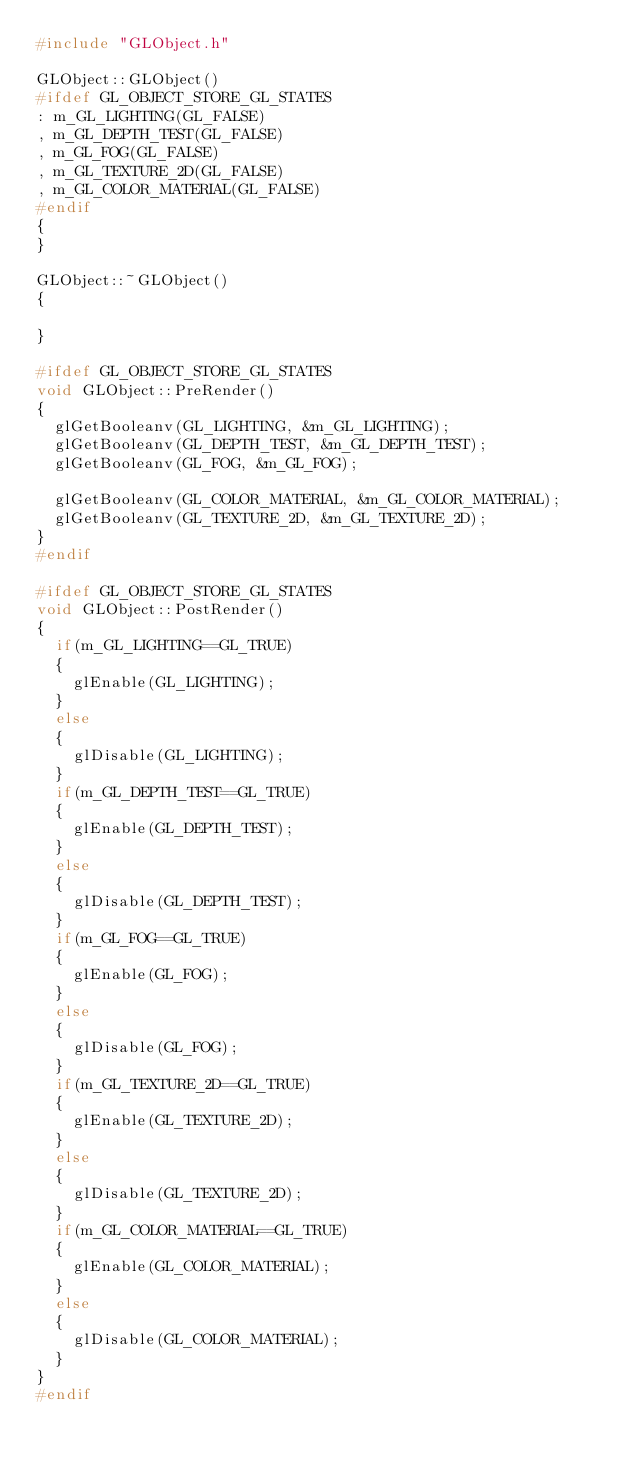Convert code to text. <code><loc_0><loc_0><loc_500><loc_500><_C++_>#include "GLObject.h"

GLObject::GLObject()
#ifdef GL_OBJECT_STORE_GL_STATES
: m_GL_LIGHTING(GL_FALSE)
, m_GL_DEPTH_TEST(GL_FALSE)
, m_GL_FOG(GL_FALSE)
, m_GL_TEXTURE_2D(GL_FALSE)
, m_GL_COLOR_MATERIAL(GL_FALSE)
#endif
{
}

GLObject::~GLObject()
{

}

#ifdef GL_OBJECT_STORE_GL_STATES
void GLObject::PreRender()
{
	glGetBooleanv(GL_LIGHTING, &m_GL_LIGHTING);
	glGetBooleanv(GL_DEPTH_TEST, &m_GL_DEPTH_TEST);
	glGetBooleanv(GL_FOG, &m_GL_FOG);

	glGetBooleanv(GL_COLOR_MATERIAL, &m_GL_COLOR_MATERIAL);
	glGetBooleanv(GL_TEXTURE_2D, &m_GL_TEXTURE_2D);
}
#endif

#ifdef GL_OBJECT_STORE_GL_STATES
void GLObject::PostRender()
{
	if(m_GL_LIGHTING==GL_TRUE)
	{
		glEnable(GL_LIGHTING);
	}
	else
	{
		glDisable(GL_LIGHTING);
	}
	if(m_GL_DEPTH_TEST==GL_TRUE)
	{
		glEnable(GL_DEPTH_TEST);
	}
	else
	{
		glDisable(GL_DEPTH_TEST);
	}
	if(m_GL_FOG==GL_TRUE)
	{
		glEnable(GL_FOG);
	}
	else
	{
		glDisable(GL_FOG);
	}
	if(m_GL_TEXTURE_2D==GL_TRUE)
	{
		glEnable(GL_TEXTURE_2D);
	}
	else
	{
		glDisable(GL_TEXTURE_2D);
	}
	if(m_GL_COLOR_MATERIAL==GL_TRUE)
	{
		glEnable(GL_COLOR_MATERIAL);
	}
	else
	{
		glDisable(GL_COLOR_MATERIAL);
	}
}
#endif</code> 